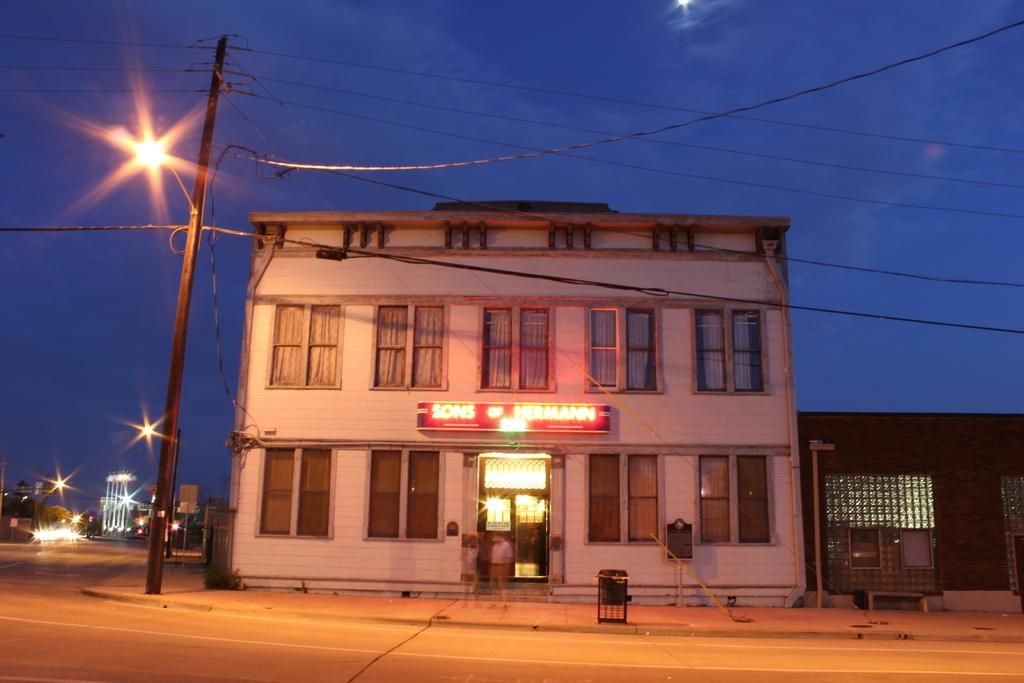What type of structure is visible in the image? There is a building in the image. What can be seen behind the building? Street lights are present behind the building. How many people are standing on the footpath? There are two persons standing on the footpath. Where is the footpath located in relation to the road? The footpath is in front of a road. What is visible above the building? The sky is visible above the building. What type of comfort can be seen on the building's roof in the image? There is no visible comfort on the building's roof in the image. 